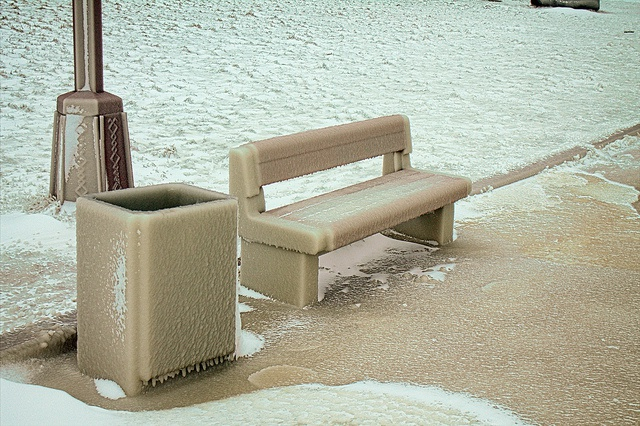Describe the objects in this image and their specific colors. I can see a bench in gray, tan, and ivory tones in this image. 